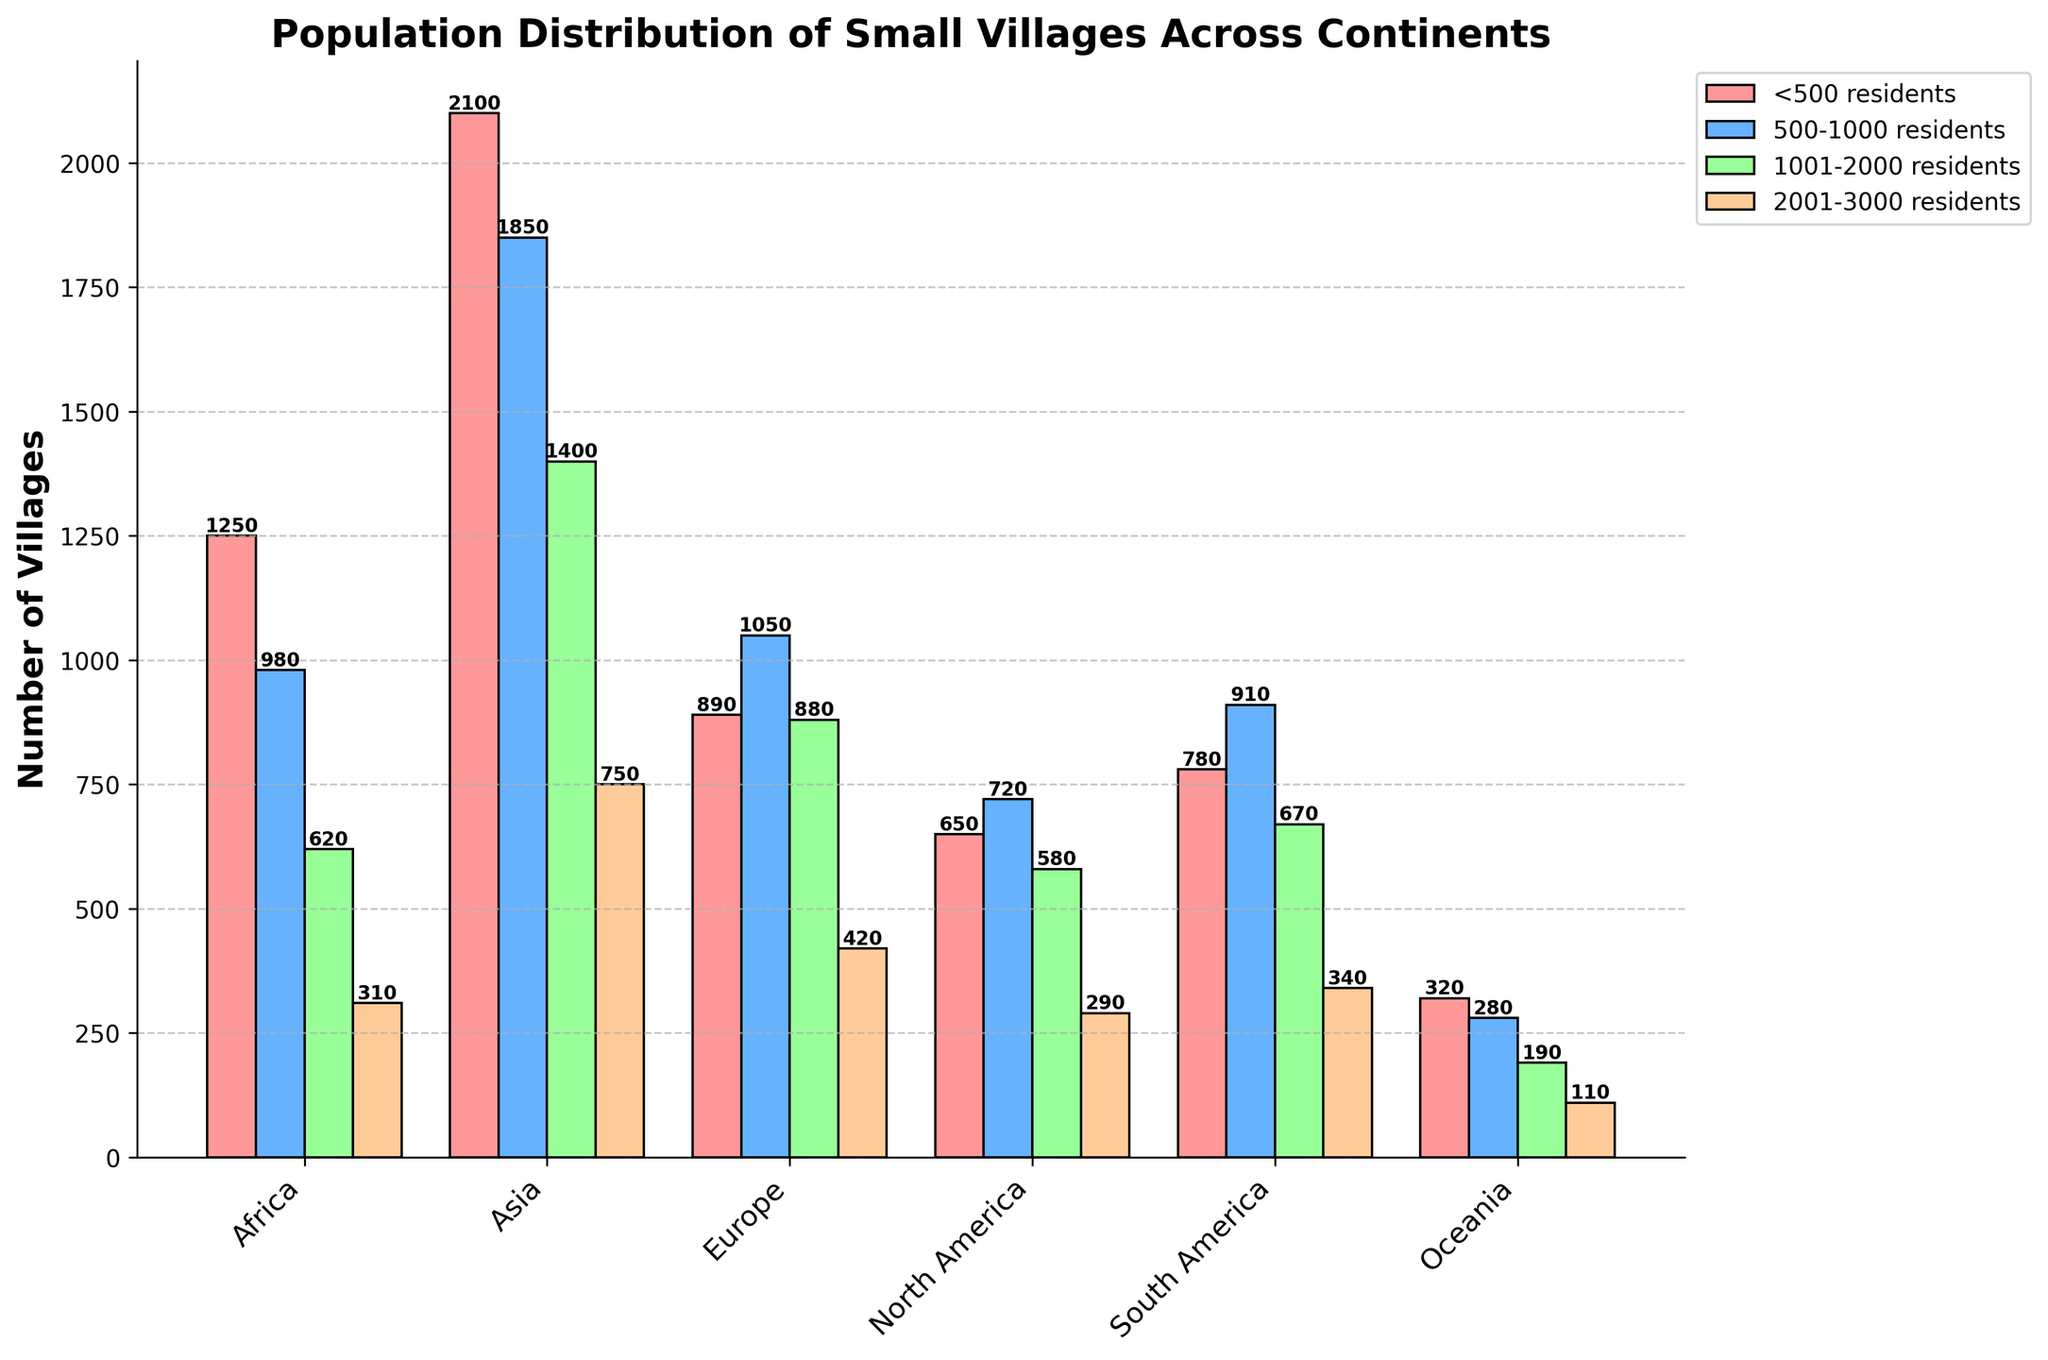Which continent has the highest number of villages with less than 500 residents? By observing the height of the bars in the "<500 residents" category, Asia has the highest bar, indicating the highest number.
Answer: Asia How many total villages in Europe have between 1001 and 3000 residents? Sum the values in the categories "1001-2000 residents" and "2001-3000 residents" for Europe: 880 + 420.
Answer: 1300 What is the difference in the number of villages with 500-1000 residents between Africa and Oceania? Subtract the number of villages in Oceania from Africa in the "500-1000 residents" category: 980 - 280.
Answer: 700 Which continent has the fewest villages with 2001-3000 residents? By observing the height of the bars in the "2001-3000 residents" category, Oceania has the smallest bar.
Answer: Oceania In South America, are there more villages in the <500 residents category or the 500-1000 residents category? Compare the heights of the respective bars for South America: 780 (500-1000 residents) vs. 780 (<500 residents).
Answer: Equal What is the average number of villages with 1001-2000 residents across all continents? Sum the values for "1001-2000 residents": 620 + 1400 + 880 + 580 + 670 + 190 = 4340, Then divide by the number of continents: 4340 / 6.
Answer: 723.33 Are there more total villages in North America or Oceania across all categories? Sum the values for each continent: North America (650+720+580+290 = 2240) and Oceania (320+280+190+110 = 900). Compare: 2240 > 900.
Answer: North America For which continent is the number of villages in the 500-1000 residents category closest to the number in the 2001-3000 residents category? Compare the values in the "500-1000 residents" and "2001-3000 residents" categories for each continent. North America has 720 and 290, the smallest difference of 430.
Answer: North America Which color represents villages with 1001-2000 residents and how many of such villages are there in Asia? The bar color for "1001-2000 residents" is green. In Asia, by observing the height of the green bar, there are 1400 villages.
Answer: Green, 1400 What is the combined total number of villages with less than 500 residents in Africa, Europe, and North America? Sum the values for "<500 residents" category in Africa, Europe, and North America: 1250 + 890 + 650.
Answer: 2,790 